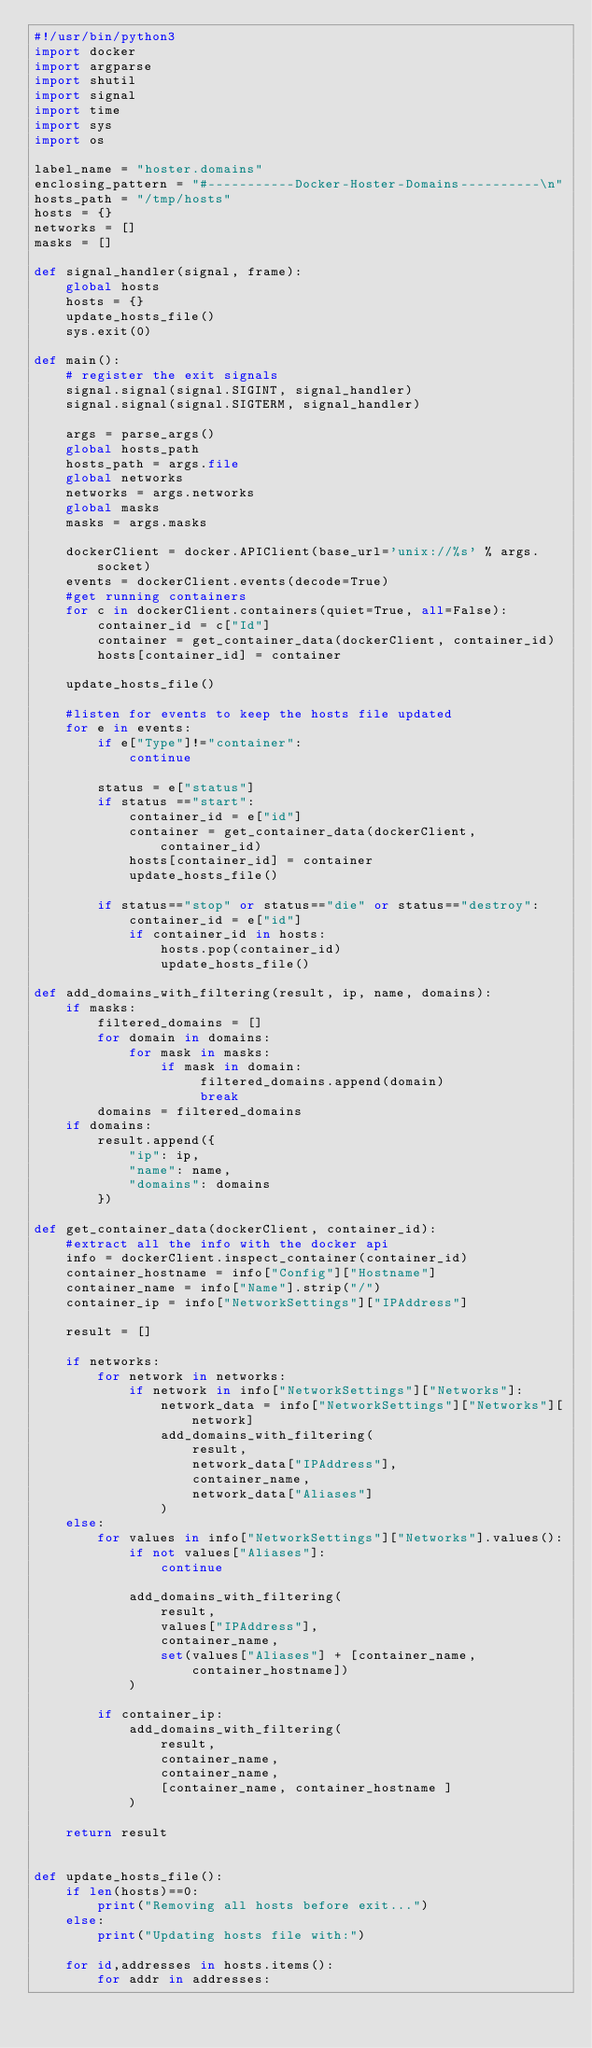<code> <loc_0><loc_0><loc_500><loc_500><_Python_>#!/usr/bin/python3
import docker
import argparse
import shutil
import signal
import time
import sys
import os

label_name = "hoster.domains"
enclosing_pattern = "#-----------Docker-Hoster-Domains----------\n"
hosts_path = "/tmp/hosts"
hosts = {}
networks = []
masks = []

def signal_handler(signal, frame):
    global hosts
    hosts = {}
    update_hosts_file()
    sys.exit(0)

def main():
    # register the exit signals
    signal.signal(signal.SIGINT, signal_handler)
    signal.signal(signal.SIGTERM, signal_handler)

    args = parse_args()
    global hosts_path
    hosts_path = args.file
    global networks
    networks = args.networks
    global masks
    masks = args.masks

    dockerClient = docker.APIClient(base_url='unix://%s' % args.socket)
    events = dockerClient.events(decode=True)
    #get running containers
    for c in dockerClient.containers(quiet=True, all=False):
        container_id = c["Id"]
        container = get_container_data(dockerClient, container_id)
        hosts[container_id] = container

    update_hosts_file()

    #listen for events to keep the hosts file updated
    for e in events:
        if e["Type"]!="container": 
            continue
        
        status = e["status"]
        if status =="start":
            container_id = e["id"]
            container = get_container_data(dockerClient, container_id)
            hosts[container_id] = container
            update_hosts_file()

        if status=="stop" or status=="die" or status=="destroy":
            container_id = e["id"]
            if container_id in hosts:
                hosts.pop(container_id)
                update_hosts_file()

def add_domains_with_filtering(result, ip, name, domains):
    if masks:
        filtered_domains = []
        for domain in domains:
            for mask in masks:
                if mask in domain:
                     filtered_domains.append(domain)
                     break
        domains = filtered_domains
    if domains:
        result.append({
            "ip": ip,
            "name": name,
            "domains": domains
        })

def get_container_data(dockerClient, container_id):
    #extract all the info with the docker api
    info = dockerClient.inspect_container(container_id)
    container_hostname = info["Config"]["Hostname"]
    container_name = info["Name"].strip("/")
    container_ip = info["NetworkSettings"]["IPAddress"]

    result = []

    if networks:
        for network in networks:
            if network in info["NetworkSettings"]["Networks"]:
                network_data = info["NetworkSettings"]["Networks"][network]
                add_domains_with_filtering(
                    result,
                    network_data["IPAddress"],
                    container_name,
                    network_data["Aliases"]
                )
    else:
        for values in info["NetworkSettings"]["Networks"].values():
            if not values["Aliases"]:
                continue

            add_domains_with_filtering(
                result,
                values["IPAddress"],
                container_name,
                set(values["Aliases"] + [container_name, container_hostname])
            )

        if container_ip:
            add_domains_with_filtering(
                result,
                container_name,
                container_name,
                [container_name, container_hostname ]
            )

    return result


def update_hosts_file():
    if len(hosts)==0:
        print("Removing all hosts before exit...")
    else:
        print("Updating hosts file with:")

    for id,addresses in hosts.items():
        for addr in addresses:</code> 